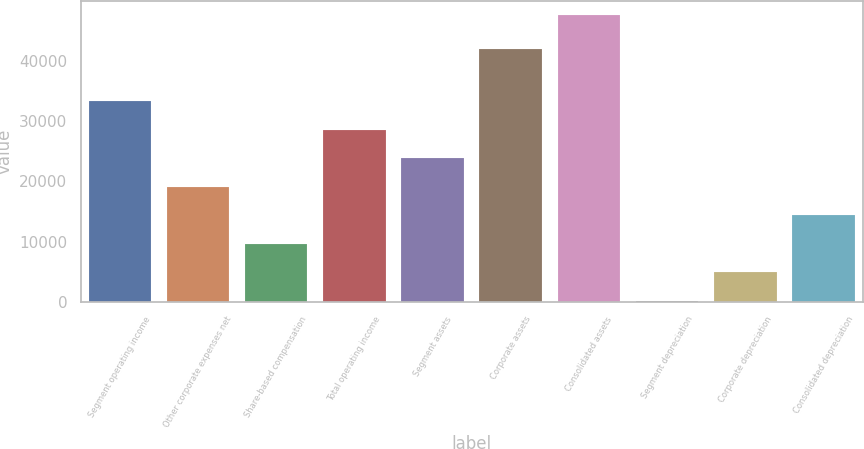Convert chart. <chart><loc_0><loc_0><loc_500><loc_500><bar_chart><fcel>Segment operating income<fcel>Other corporate expenses net<fcel>Share-based compensation<fcel>Total operating income<fcel>Segment assets<fcel>Corporate assets<fcel>Consolidated assets<fcel>Segment depreciation<fcel>Corporate depreciation<fcel>Consolidated depreciation<nl><fcel>33301.7<fcel>19102.4<fcel>9636.2<fcel>28568.6<fcel>23835.5<fcel>41897<fcel>47501<fcel>170<fcel>4903.1<fcel>14369.3<nl></chart> 